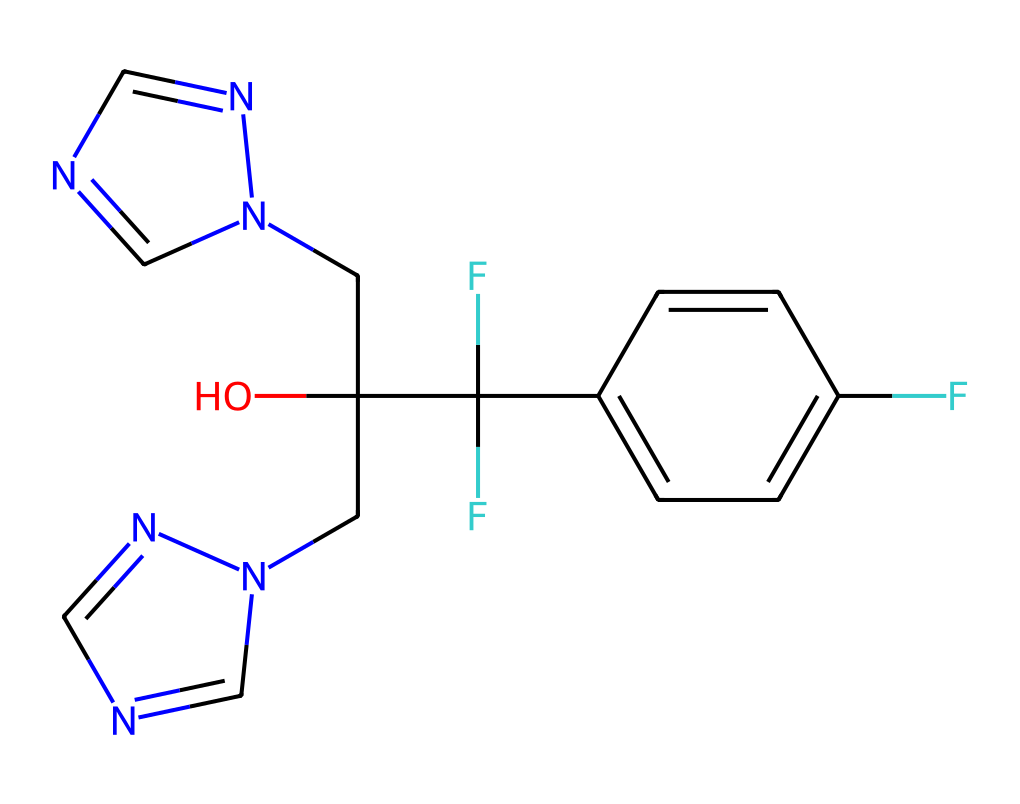What is the molecular formula of fluconazole? The molecular formula can be determined by counting the atoms of each element represented in the SMILES. There are 13 carbon atoms, 12 hydrogen atoms, 4 nitrogen atoms, and 2 oxygen atoms, so the molecular formula is C13H12F2N4O.
Answer: C13H12F2N4O How many nitrogen atoms are in fluconazole? In the given SMILES representation, the letter 'n' represents nitrogen atoms. By counting the 'n' occurrences in the structure, we find there are four nitrogen atoms.
Answer: 4 What type of functional groups are present in fluconazole? The chemical structure contains a hydroxyl group (–OH) and difluoromethyl groups (–CF2) due to the presence of F atoms and O atoms as well.
Answer: hydroxyl and difluoromethyl What is the number of carbon-carbon bonds in fluconazole? To find the number of carbon-carbon bonds, we identify the carbon atoms connected directly to one another in the structure. Counting these connections gives us 10 carbon-carbon bonds.
Answer: 10 Which part of fluconazole contributes to its antifungal properties? The presence of the triazole ring in the structure, represented by the connected nitrogen-containing rings, allows it to inhibit fungal growth, making it effective as an antifungal agent.
Answer: triazole ring What is the significance of the fluorine atoms in fluconazole? The fluorine atoms enhance the lipophilicity of the compound, which improves its ability to penetrate fungal cell membranes and increases its antifungal activity.
Answer: lipophilicity 